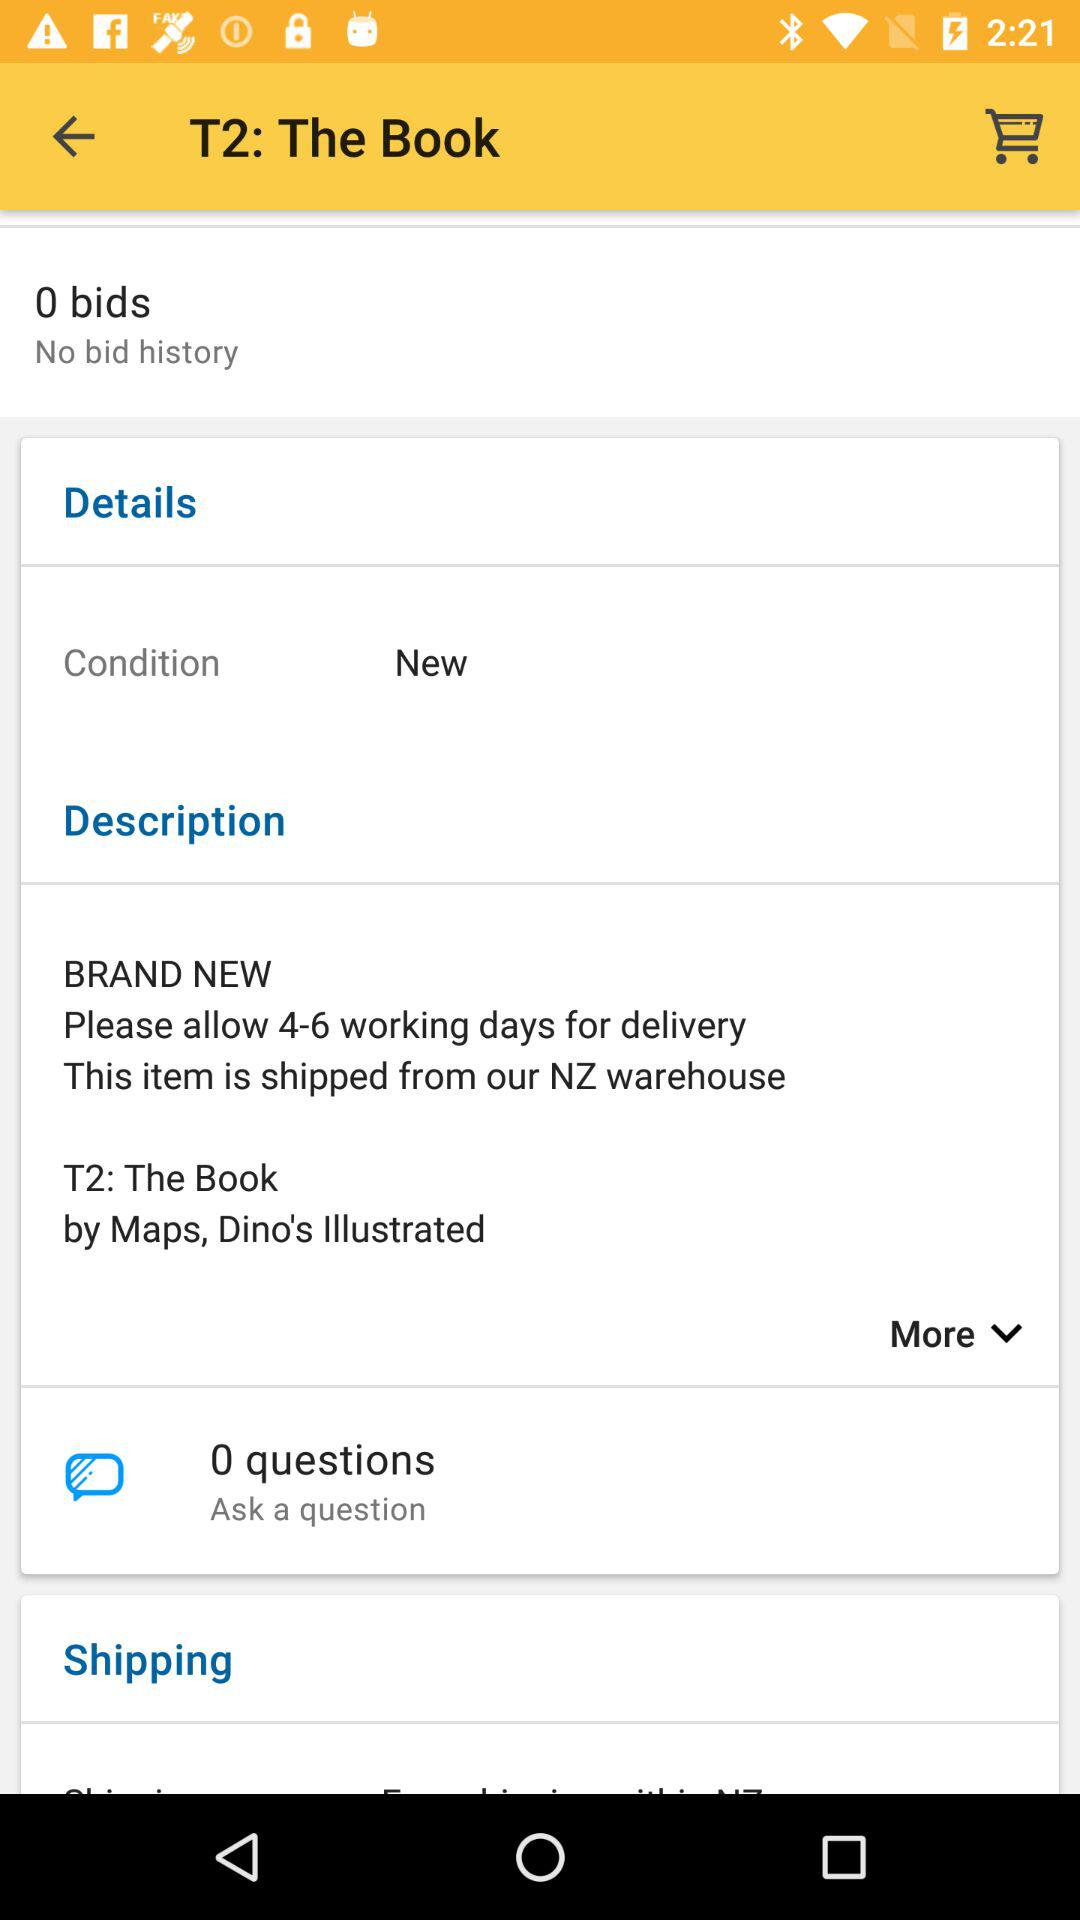How many bids are shown on the screen? There are 0 bids shown on the screen. 